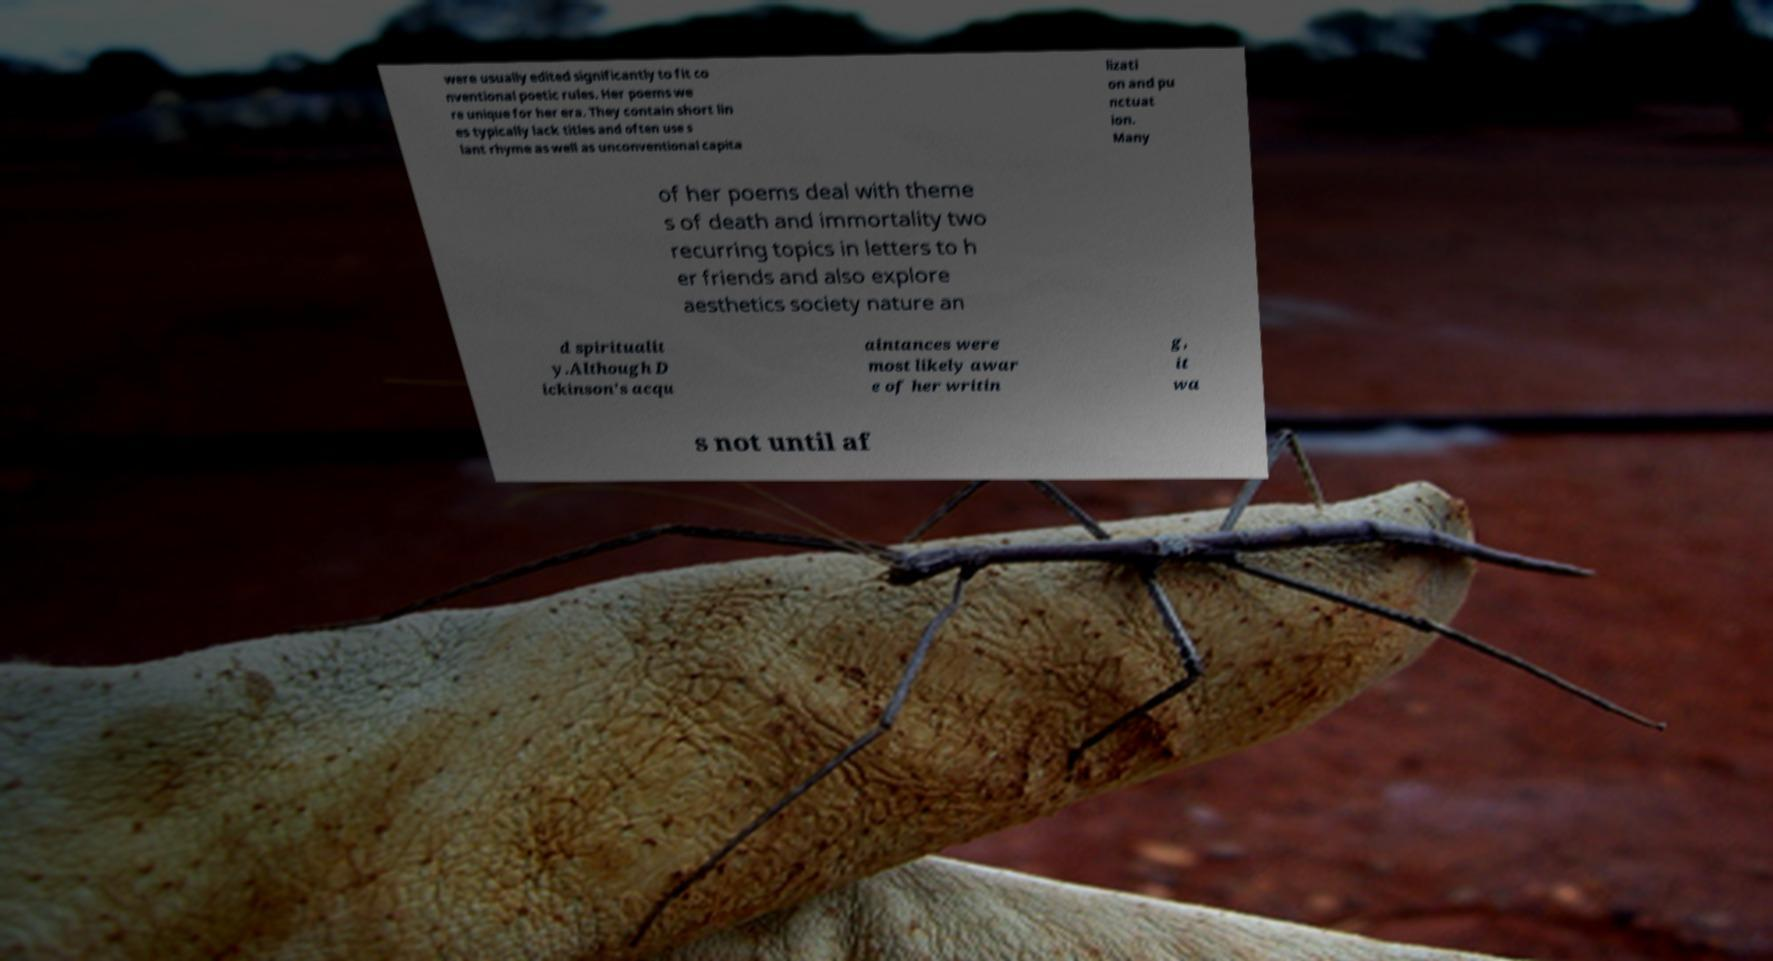What messages or text are displayed in this image? I need them in a readable, typed format. were usually edited significantly to fit co nventional poetic rules. Her poems we re unique for her era. They contain short lin es typically lack titles and often use s lant rhyme as well as unconventional capita lizati on and pu nctuat ion. Many of her poems deal with theme s of death and immortality two recurring topics in letters to h er friends and also explore aesthetics society nature an d spiritualit y.Although D ickinson's acqu aintances were most likely awar e of her writin g, it wa s not until af 